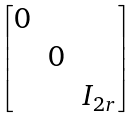Convert formula to latex. <formula><loc_0><loc_0><loc_500><loc_500>\begin{bmatrix} 0 & & \\ & 0 & \\ & & I _ { 2 r } \end{bmatrix}</formula> 